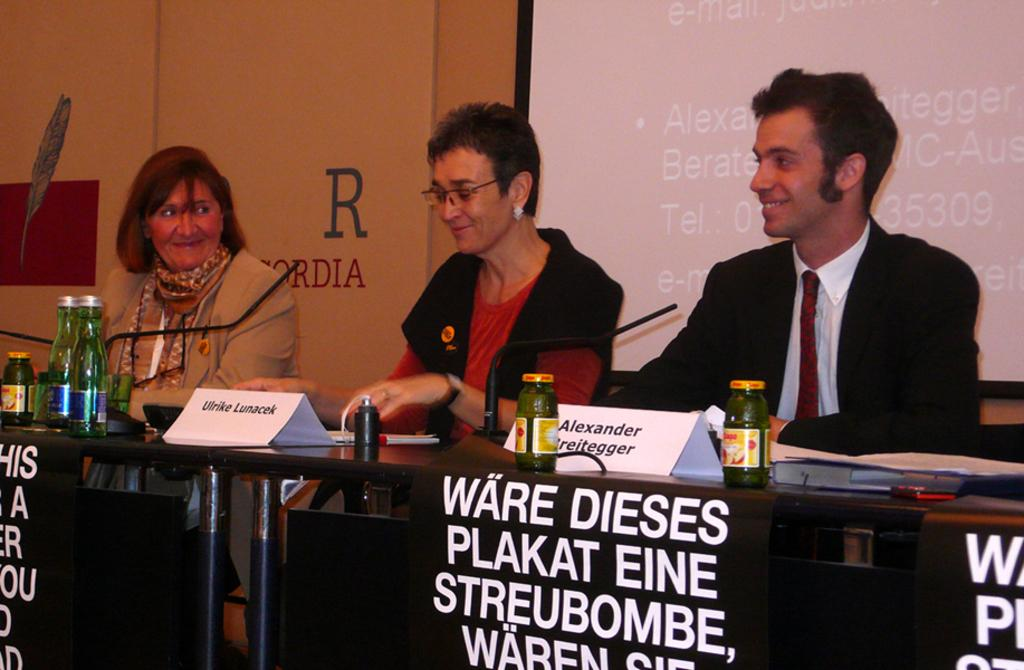What is the man in the image wearing? The man in the image is wearing a suit. How many women are in the image? There are two women in the image. Where are the man and women sitting in the image? The man and women are sitting in front of a table. What objects can be seen on the table in the image? There is a microphone, glass bottles, jars, and a laptop on the table. What is on the wall behind the man and women? There is a screen on the wall behind them. What type of pickle is being discussed in the image? There is no mention of pickles in the image. What degree do the women in the image hold? The image does not provide information about the degrees held by the women. 